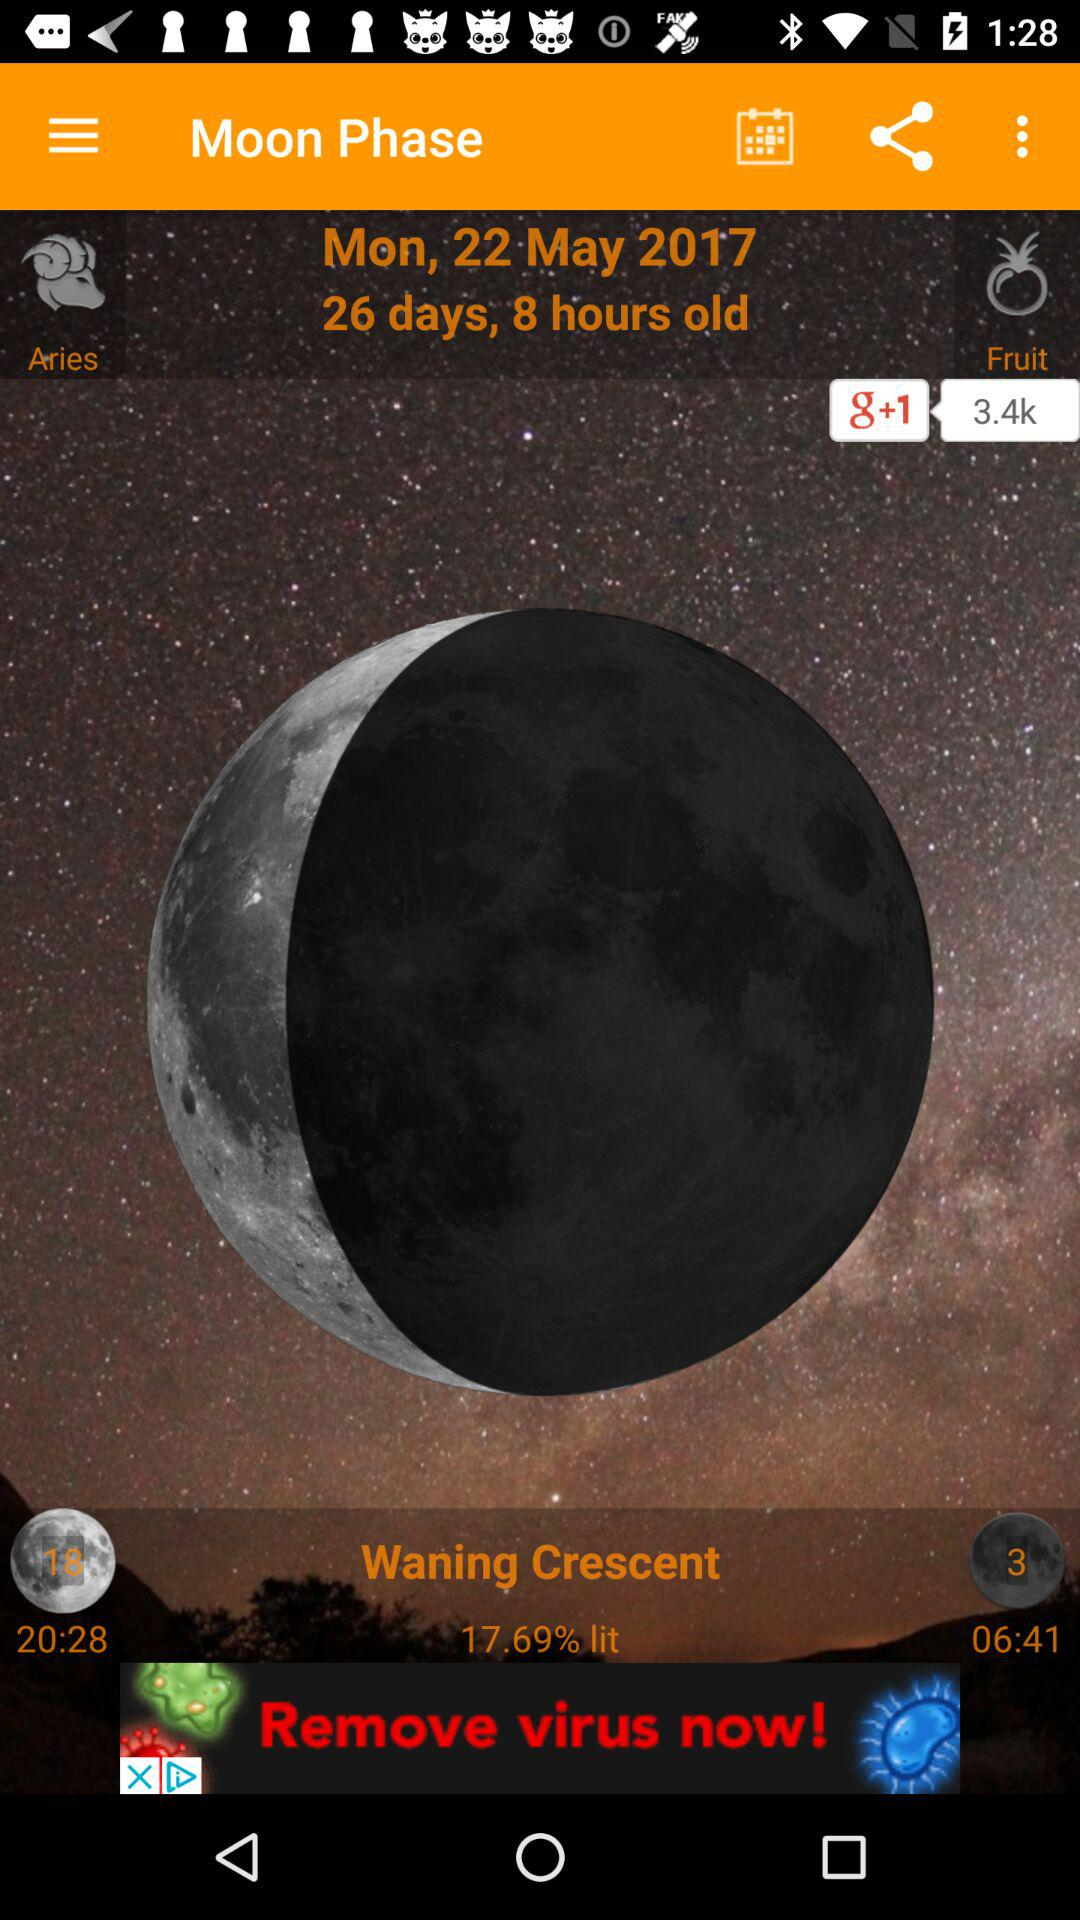How many days old is the moon phase? The moon phase is 26 days and 8 hours old. 